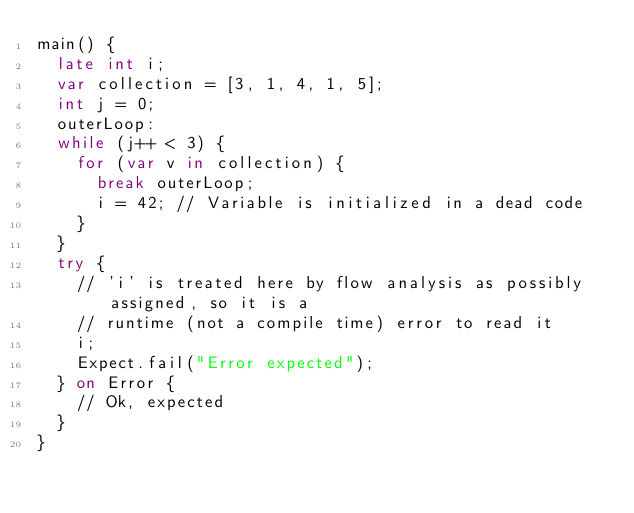<code> <loc_0><loc_0><loc_500><loc_500><_Dart_>main() {
  late int i;
  var collection = [3, 1, 4, 1, 5];
  int j = 0;
  outerLoop:
  while (j++ < 3) {
    for (var v in collection) {
      break outerLoop;
      i = 42; // Variable is initialized in a dead code
    }
  }
  try {
    // 'i' is treated here by flow analysis as possibly assigned, so it is a
    // runtime (not a compile time) error to read it
    i;
    Expect.fail("Error expected");
  } on Error {
    // Ok, expected
  }
}
</code> 